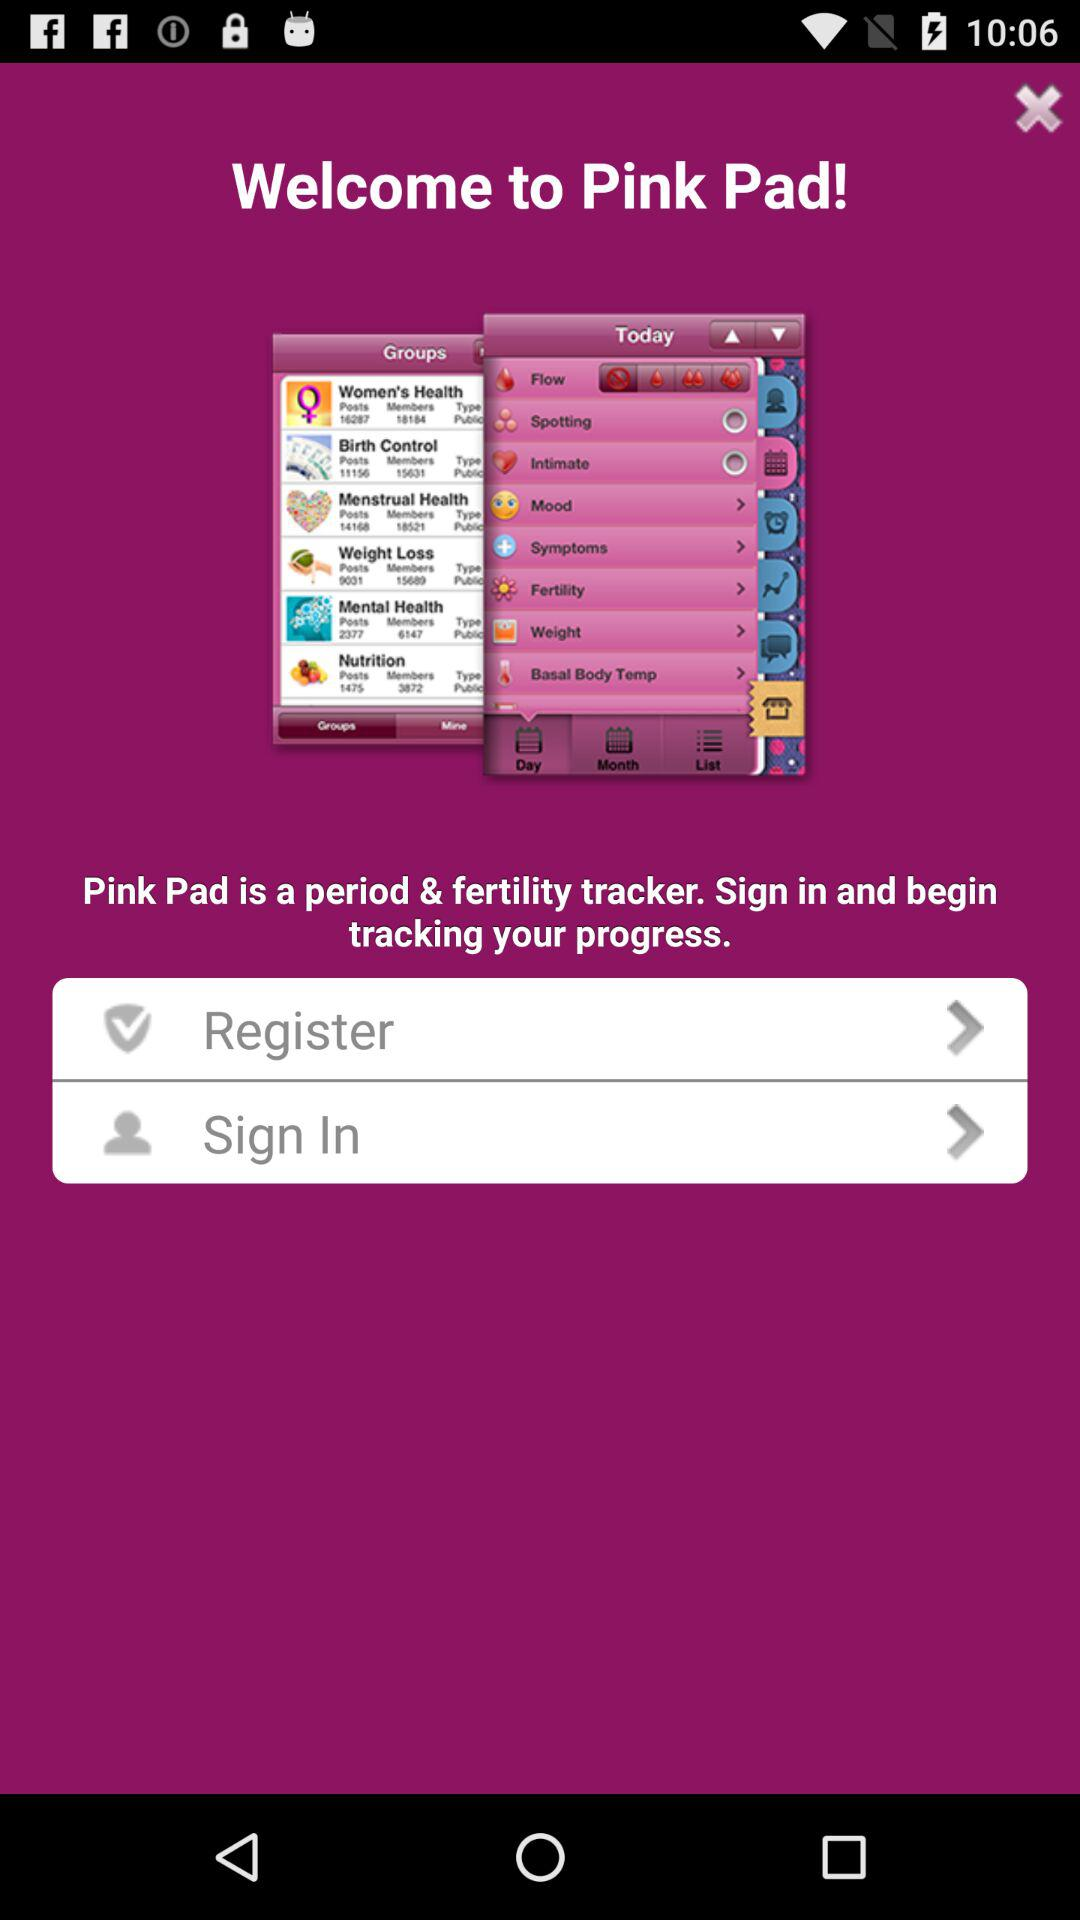What is the application name? The application name is "Pink Pad". 